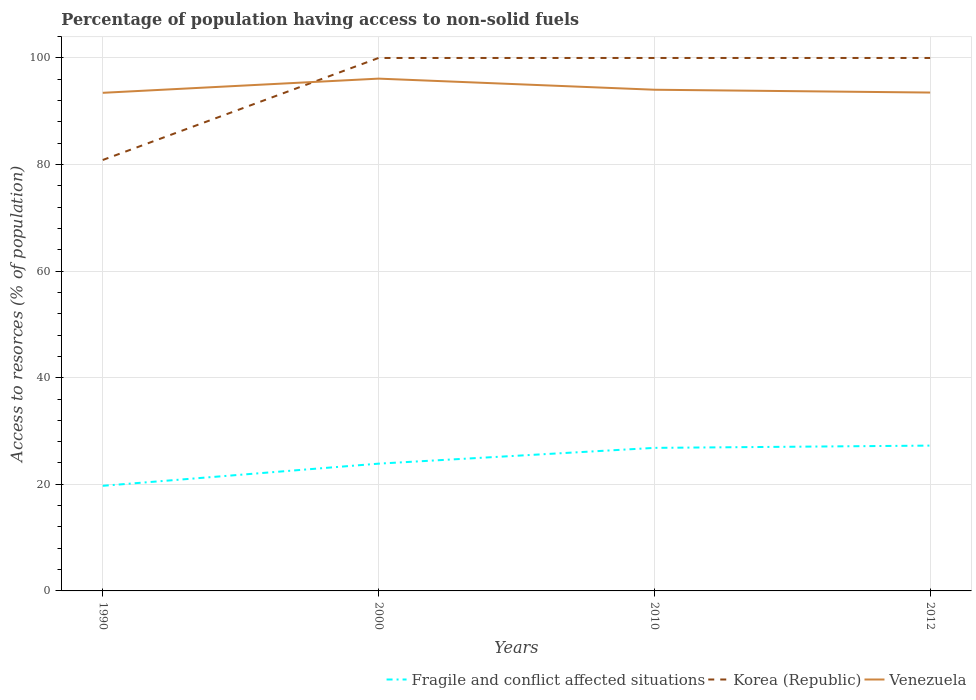How many different coloured lines are there?
Provide a succinct answer. 3. Is the number of lines equal to the number of legend labels?
Make the answer very short. Yes. Across all years, what is the maximum percentage of population having access to non-solid fuels in Korea (Republic)?
Provide a succinct answer. 80.85. In which year was the percentage of population having access to non-solid fuels in Korea (Republic) maximum?
Provide a short and direct response. 1990. What is the total percentage of population having access to non-solid fuels in Venezuela in the graph?
Your answer should be compact. 0.53. What is the difference between the highest and the second highest percentage of population having access to non-solid fuels in Korea (Republic)?
Your response must be concise. 19.14. What is the difference between the highest and the lowest percentage of population having access to non-solid fuels in Korea (Republic)?
Your response must be concise. 3. Are the values on the major ticks of Y-axis written in scientific E-notation?
Keep it short and to the point. No. Does the graph contain grids?
Offer a terse response. Yes. Where does the legend appear in the graph?
Ensure brevity in your answer.  Bottom right. How are the legend labels stacked?
Ensure brevity in your answer.  Horizontal. What is the title of the graph?
Provide a succinct answer. Percentage of population having access to non-solid fuels. Does "High income: OECD" appear as one of the legend labels in the graph?
Your response must be concise. No. What is the label or title of the X-axis?
Your response must be concise. Years. What is the label or title of the Y-axis?
Make the answer very short. Access to resorces (% of population). What is the Access to resorces (% of population) in Fragile and conflict affected situations in 1990?
Your answer should be compact. 19.72. What is the Access to resorces (% of population) of Korea (Republic) in 1990?
Your response must be concise. 80.85. What is the Access to resorces (% of population) in Venezuela in 1990?
Keep it short and to the point. 93.45. What is the Access to resorces (% of population) of Fragile and conflict affected situations in 2000?
Offer a very short reply. 23.88. What is the Access to resorces (% of population) in Korea (Republic) in 2000?
Provide a succinct answer. 99.99. What is the Access to resorces (% of population) of Venezuela in 2000?
Offer a terse response. 96.12. What is the Access to resorces (% of population) in Fragile and conflict affected situations in 2010?
Give a very brief answer. 26.84. What is the Access to resorces (% of population) of Korea (Republic) in 2010?
Provide a succinct answer. 99.99. What is the Access to resorces (% of population) of Venezuela in 2010?
Give a very brief answer. 94.03. What is the Access to resorces (% of population) in Fragile and conflict affected situations in 2012?
Make the answer very short. 27.26. What is the Access to resorces (% of population) of Korea (Republic) in 2012?
Your answer should be compact. 99.99. What is the Access to resorces (% of population) in Venezuela in 2012?
Make the answer very short. 93.5. Across all years, what is the maximum Access to resorces (% of population) of Fragile and conflict affected situations?
Ensure brevity in your answer.  27.26. Across all years, what is the maximum Access to resorces (% of population) of Korea (Republic)?
Offer a terse response. 99.99. Across all years, what is the maximum Access to resorces (% of population) in Venezuela?
Provide a succinct answer. 96.12. Across all years, what is the minimum Access to resorces (% of population) of Fragile and conflict affected situations?
Give a very brief answer. 19.72. Across all years, what is the minimum Access to resorces (% of population) of Korea (Republic)?
Keep it short and to the point. 80.85. Across all years, what is the minimum Access to resorces (% of population) in Venezuela?
Make the answer very short. 93.45. What is the total Access to resorces (% of population) in Fragile and conflict affected situations in the graph?
Ensure brevity in your answer.  97.7. What is the total Access to resorces (% of population) in Korea (Republic) in the graph?
Your answer should be very brief. 380.82. What is the total Access to resorces (% of population) in Venezuela in the graph?
Ensure brevity in your answer.  377.1. What is the difference between the Access to resorces (% of population) of Fragile and conflict affected situations in 1990 and that in 2000?
Offer a terse response. -4.16. What is the difference between the Access to resorces (% of population) in Korea (Republic) in 1990 and that in 2000?
Keep it short and to the point. -19.14. What is the difference between the Access to resorces (% of population) in Venezuela in 1990 and that in 2000?
Offer a terse response. -2.66. What is the difference between the Access to resorces (% of population) in Fragile and conflict affected situations in 1990 and that in 2010?
Make the answer very short. -7.12. What is the difference between the Access to resorces (% of population) in Korea (Republic) in 1990 and that in 2010?
Your response must be concise. -19.14. What is the difference between the Access to resorces (% of population) in Venezuela in 1990 and that in 2010?
Ensure brevity in your answer.  -0.58. What is the difference between the Access to resorces (% of population) of Fragile and conflict affected situations in 1990 and that in 2012?
Your response must be concise. -7.54. What is the difference between the Access to resorces (% of population) of Korea (Republic) in 1990 and that in 2012?
Give a very brief answer. -19.14. What is the difference between the Access to resorces (% of population) in Venezuela in 1990 and that in 2012?
Make the answer very short. -0.05. What is the difference between the Access to resorces (% of population) of Fragile and conflict affected situations in 2000 and that in 2010?
Provide a succinct answer. -2.96. What is the difference between the Access to resorces (% of population) of Korea (Republic) in 2000 and that in 2010?
Your answer should be very brief. 0. What is the difference between the Access to resorces (% of population) in Venezuela in 2000 and that in 2010?
Ensure brevity in your answer.  2.08. What is the difference between the Access to resorces (% of population) of Fragile and conflict affected situations in 2000 and that in 2012?
Provide a succinct answer. -3.39. What is the difference between the Access to resorces (% of population) in Venezuela in 2000 and that in 2012?
Offer a terse response. 2.61. What is the difference between the Access to resorces (% of population) of Fragile and conflict affected situations in 2010 and that in 2012?
Make the answer very short. -0.43. What is the difference between the Access to resorces (% of population) of Korea (Republic) in 2010 and that in 2012?
Provide a short and direct response. 0. What is the difference between the Access to resorces (% of population) of Venezuela in 2010 and that in 2012?
Provide a short and direct response. 0.53. What is the difference between the Access to resorces (% of population) of Fragile and conflict affected situations in 1990 and the Access to resorces (% of population) of Korea (Republic) in 2000?
Offer a very short reply. -80.27. What is the difference between the Access to resorces (% of population) in Fragile and conflict affected situations in 1990 and the Access to resorces (% of population) in Venezuela in 2000?
Provide a short and direct response. -76.4. What is the difference between the Access to resorces (% of population) in Korea (Republic) in 1990 and the Access to resorces (% of population) in Venezuela in 2000?
Provide a short and direct response. -15.27. What is the difference between the Access to resorces (% of population) in Fragile and conflict affected situations in 1990 and the Access to resorces (% of population) in Korea (Republic) in 2010?
Make the answer very short. -80.27. What is the difference between the Access to resorces (% of population) of Fragile and conflict affected situations in 1990 and the Access to resorces (% of population) of Venezuela in 2010?
Your answer should be compact. -74.31. What is the difference between the Access to resorces (% of population) of Korea (Republic) in 1990 and the Access to resorces (% of population) of Venezuela in 2010?
Ensure brevity in your answer.  -13.18. What is the difference between the Access to resorces (% of population) of Fragile and conflict affected situations in 1990 and the Access to resorces (% of population) of Korea (Republic) in 2012?
Your answer should be compact. -80.27. What is the difference between the Access to resorces (% of population) in Fragile and conflict affected situations in 1990 and the Access to resorces (% of population) in Venezuela in 2012?
Make the answer very short. -73.78. What is the difference between the Access to resorces (% of population) in Korea (Republic) in 1990 and the Access to resorces (% of population) in Venezuela in 2012?
Make the answer very short. -12.65. What is the difference between the Access to resorces (% of population) of Fragile and conflict affected situations in 2000 and the Access to resorces (% of population) of Korea (Republic) in 2010?
Your response must be concise. -76.11. What is the difference between the Access to resorces (% of population) in Fragile and conflict affected situations in 2000 and the Access to resorces (% of population) in Venezuela in 2010?
Offer a very short reply. -70.15. What is the difference between the Access to resorces (% of population) in Korea (Republic) in 2000 and the Access to resorces (% of population) in Venezuela in 2010?
Make the answer very short. 5.96. What is the difference between the Access to resorces (% of population) of Fragile and conflict affected situations in 2000 and the Access to resorces (% of population) of Korea (Republic) in 2012?
Ensure brevity in your answer.  -76.11. What is the difference between the Access to resorces (% of population) of Fragile and conflict affected situations in 2000 and the Access to resorces (% of population) of Venezuela in 2012?
Offer a terse response. -69.62. What is the difference between the Access to resorces (% of population) of Korea (Republic) in 2000 and the Access to resorces (% of population) of Venezuela in 2012?
Keep it short and to the point. 6.49. What is the difference between the Access to resorces (% of population) in Fragile and conflict affected situations in 2010 and the Access to resorces (% of population) in Korea (Republic) in 2012?
Offer a very short reply. -73.15. What is the difference between the Access to resorces (% of population) in Fragile and conflict affected situations in 2010 and the Access to resorces (% of population) in Venezuela in 2012?
Give a very brief answer. -66.66. What is the difference between the Access to resorces (% of population) of Korea (Republic) in 2010 and the Access to resorces (% of population) of Venezuela in 2012?
Offer a very short reply. 6.49. What is the average Access to resorces (% of population) of Fragile and conflict affected situations per year?
Give a very brief answer. 24.42. What is the average Access to resorces (% of population) in Korea (Republic) per year?
Give a very brief answer. 95.2. What is the average Access to resorces (% of population) of Venezuela per year?
Provide a succinct answer. 94.28. In the year 1990, what is the difference between the Access to resorces (% of population) of Fragile and conflict affected situations and Access to resorces (% of population) of Korea (Republic)?
Your answer should be compact. -61.13. In the year 1990, what is the difference between the Access to resorces (% of population) in Fragile and conflict affected situations and Access to resorces (% of population) in Venezuela?
Keep it short and to the point. -73.73. In the year 1990, what is the difference between the Access to resorces (% of population) of Korea (Republic) and Access to resorces (% of population) of Venezuela?
Ensure brevity in your answer.  -12.6. In the year 2000, what is the difference between the Access to resorces (% of population) of Fragile and conflict affected situations and Access to resorces (% of population) of Korea (Republic)?
Your response must be concise. -76.11. In the year 2000, what is the difference between the Access to resorces (% of population) in Fragile and conflict affected situations and Access to resorces (% of population) in Venezuela?
Make the answer very short. -72.24. In the year 2000, what is the difference between the Access to resorces (% of population) in Korea (Republic) and Access to resorces (% of population) in Venezuela?
Provide a short and direct response. 3.87. In the year 2010, what is the difference between the Access to resorces (% of population) of Fragile and conflict affected situations and Access to resorces (% of population) of Korea (Republic)?
Provide a succinct answer. -73.15. In the year 2010, what is the difference between the Access to resorces (% of population) of Fragile and conflict affected situations and Access to resorces (% of population) of Venezuela?
Offer a terse response. -67.19. In the year 2010, what is the difference between the Access to resorces (% of population) in Korea (Republic) and Access to resorces (% of population) in Venezuela?
Provide a short and direct response. 5.96. In the year 2012, what is the difference between the Access to resorces (% of population) in Fragile and conflict affected situations and Access to resorces (% of population) in Korea (Republic)?
Provide a short and direct response. -72.73. In the year 2012, what is the difference between the Access to resorces (% of population) of Fragile and conflict affected situations and Access to resorces (% of population) of Venezuela?
Your answer should be very brief. -66.24. In the year 2012, what is the difference between the Access to resorces (% of population) in Korea (Republic) and Access to resorces (% of population) in Venezuela?
Make the answer very short. 6.49. What is the ratio of the Access to resorces (% of population) of Fragile and conflict affected situations in 1990 to that in 2000?
Your answer should be compact. 0.83. What is the ratio of the Access to resorces (% of population) of Korea (Republic) in 1990 to that in 2000?
Provide a succinct answer. 0.81. What is the ratio of the Access to resorces (% of population) in Venezuela in 1990 to that in 2000?
Keep it short and to the point. 0.97. What is the ratio of the Access to resorces (% of population) in Fragile and conflict affected situations in 1990 to that in 2010?
Offer a very short reply. 0.73. What is the ratio of the Access to resorces (% of population) in Korea (Republic) in 1990 to that in 2010?
Give a very brief answer. 0.81. What is the ratio of the Access to resorces (% of population) of Venezuela in 1990 to that in 2010?
Ensure brevity in your answer.  0.99. What is the ratio of the Access to resorces (% of population) of Fragile and conflict affected situations in 1990 to that in 2012?
Keep it short and to the point. 0.72. What is the ratio of the Access to resorces (% of population) in Korea (Republic) in 1990 to that in 2012?
Give a very brief answer. 0.81. What is the ratio of the Access to resorces (% of population) in Venezuela in 1990 to that in 2012?
Your answer should be compact. 1. What is the ratio of the Access to resorces (% of population) of Fragile and conflict affected situations in 2000 to that in 2010?
Provide a succinct answer. 0.89. What is the ratio of the Access to resorces (% of population) in Venezuela in 2000 to that in 2010?
Your answer should be very brief. 1.02. What is the ratio of the Access to resorces (% of population) in Fragile and conflict affected situations in 2000 to that in 2012?
Give a very brief answer. 0.88. What is the ratio of the Access to resorces (% of population) in Korea (Republic) in 2000 to that in 2012?
Your answer should be compact. 1. What is the ratio of the Access to resorces (% of population) of Venezuela in 2000 to that in 2012?
Provide a succinct answer. 1.03. What is the ratio of the Access to resorces (% of population) of Fragile and conflict affected situations in 2010 to that in 2012?
Offer a terse response. 0.98. What is the ratio of the Access to resorces (% of population) of Korea (Republic) in 2010 to that in 2012?
Your answer should be compact. 1. What is the difference between the highest and the second highest Access to resorces (% of population) of Fragile and conflict affected situations?
Keep it short and to the point. 0.43. What is the difference between the highest and the second highest Access to resorces (% of population) of Korea (Republic)?
Your answer should be compact. 0. What is the difference between the highest and the second highest Access to resorces (% of population) of Venezuela?
Ensure brevity in your answer.  2.08. What is the difference between the highest and the lowest Access to resorces (% of population) of Fragile and conflict affected situations?
Provide a succinct answer. 7.54. What is the difference between the highest and the lowest Access to resorces (% of population) of Korea (Republic)?
Make the answer very short. 19.14. What is the difference between the highest and the lowest Access to resorces (% of population) in Venezuela?
Give a very brief answer. 2.66. 